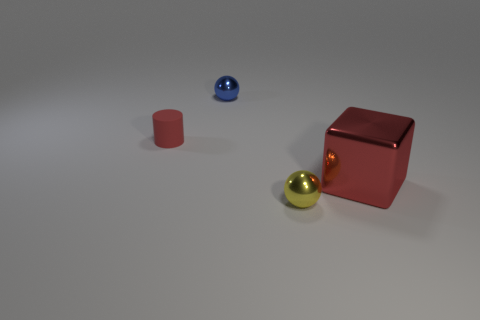What is the material of the other object that is the same shape as the small yellow metallic thing?
Offer a very short reply. Metal. Is there any other thing that is made of the same material as the small cylinder?
Provide a succinct answer. No. Does the large metallic object have the same color as the rubber thing?
Make the answer very short. Yes. What shape is the red thing that is on the right side of the small ball that is to the left of the tiny yellow shiny sphere?
Ensure brevity in your answer.  Cube. There is a big thing that is the same material as the yellow sphere; what is its shape?
Ensure brevity in your answer.  Cube. What number of other things are the same shape as the big red shiny thing?
Offer a terse response. 0. There is a red object that is to the right of the matte cylinder; is its size the same as the matte thing?
Provide a succinct answer. No. Are there more cubes that are to the right of the large red object than matte cylinders?
Make the answer very short. No. How many tiny blue metal balls are on the right side of the tiny metallic object left of the small yellow metal ball?
Keep it short and to the point. 0. Is the number of tiny red matte things that are to the left of the tiny red rubber cylinder less than the number of big green metal spheres?
Ensure brevity in your answer.  No. 